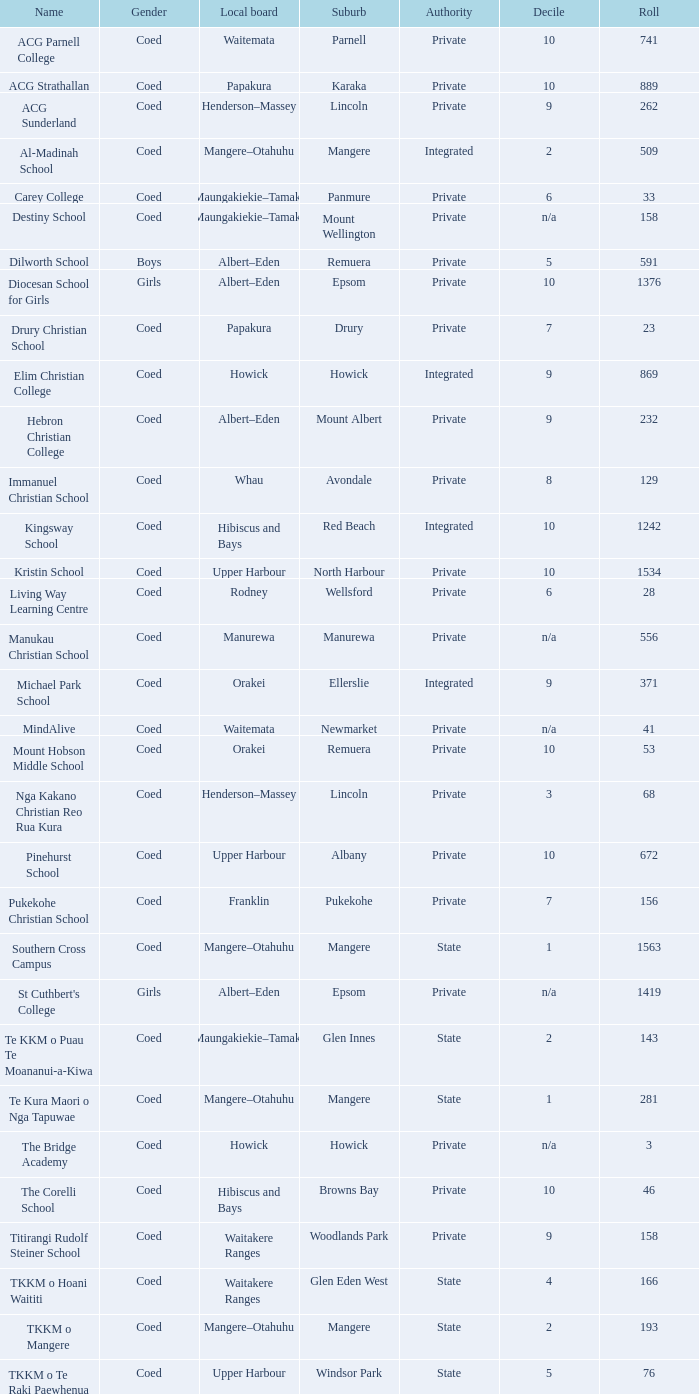What sex has an albert-eden regional board with a roll exceeding 232 and a decile of 5? Boys. 